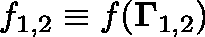<formula> <loc_0><loc_0><loc_500><loc_500>f _ { 1 , 2 } \equiv f ( { \Gamma } _ { 1 , 2 } )</formula> 